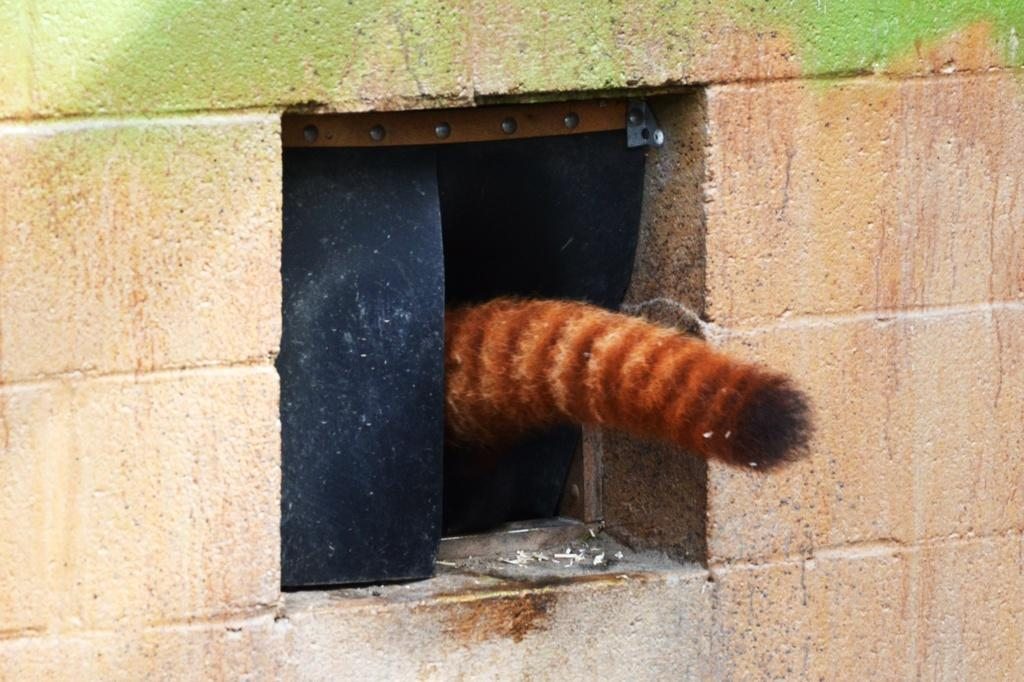What type of structure is present in the image? There is a wall in the image. Is there any entrance visible in the image? Yes, there is a small door in the image. Can you describe any specific features of the image? There is a tail visible in the image. Where is the drawer located in the image? There is no drawer present in the image. What type of oil can be seen dripping from the tail in the image? There is no oil present in the image, nor is there any tail that could be dripping oil. 